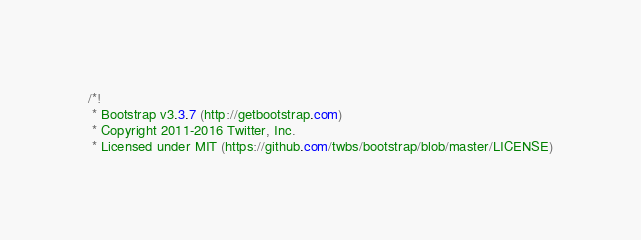Convert code to text. <code><loc_0><loc_0><loc_500><loc_500><_CSS_>/*!
 * Bootstrap v3.3.7 (http://getbootstrap.com)
 * Copyright 2011-2016 Twitter, Inc.
 * Licensed under MIT (https://github.com/twbs/bootstrap/blob/master/LICENSE)</code> 